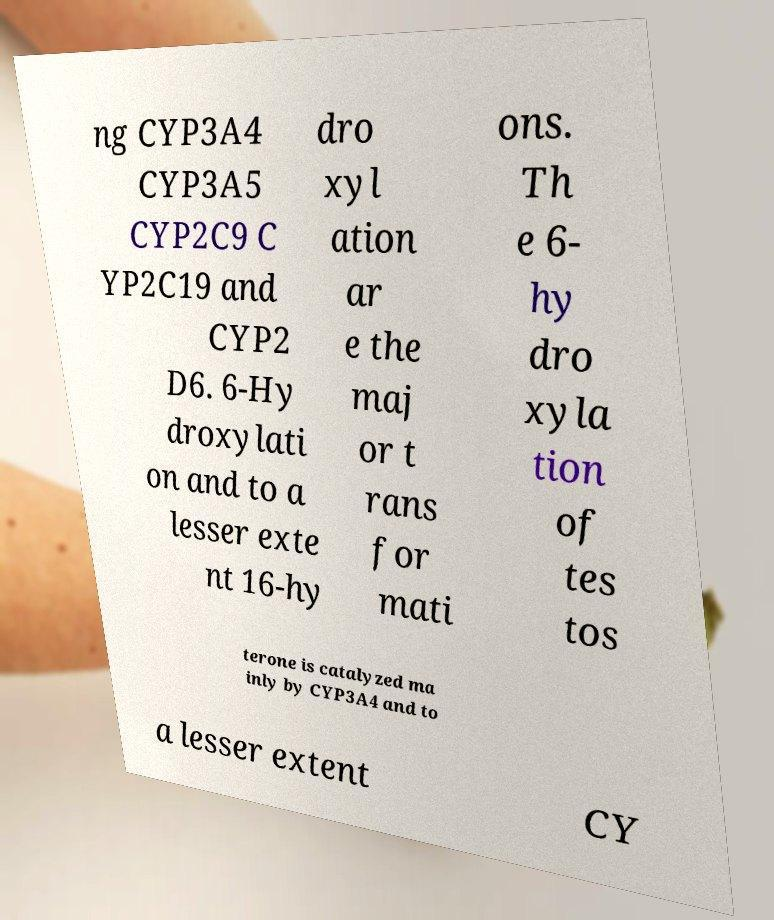There's text embedded in this image that I need extracted. Can you transcribe it verbatim? ng CYP3A4 CYP3A5 CYP2C9 C YP2C19 and CYP2 D6. 6-Hy droxylati on and to a lesser exte nt 16-hy dro xyl ation ar e the maj or t rans for mati ons. Th e 6- hy dro xyla tion of tes tos terone is catalyzed ma inly by CYP3A4 and to a lesser extent CY 